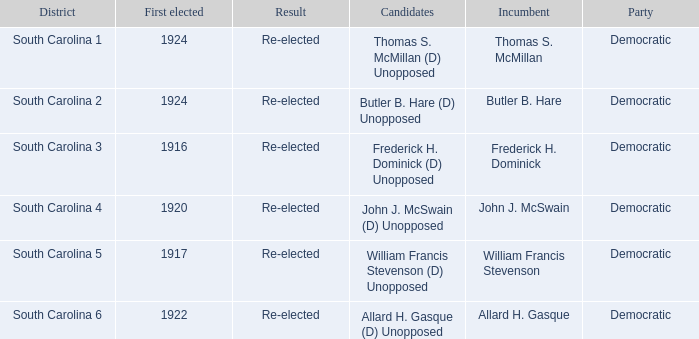What is the total number of results where the district is south carolina 5? 1.0. 